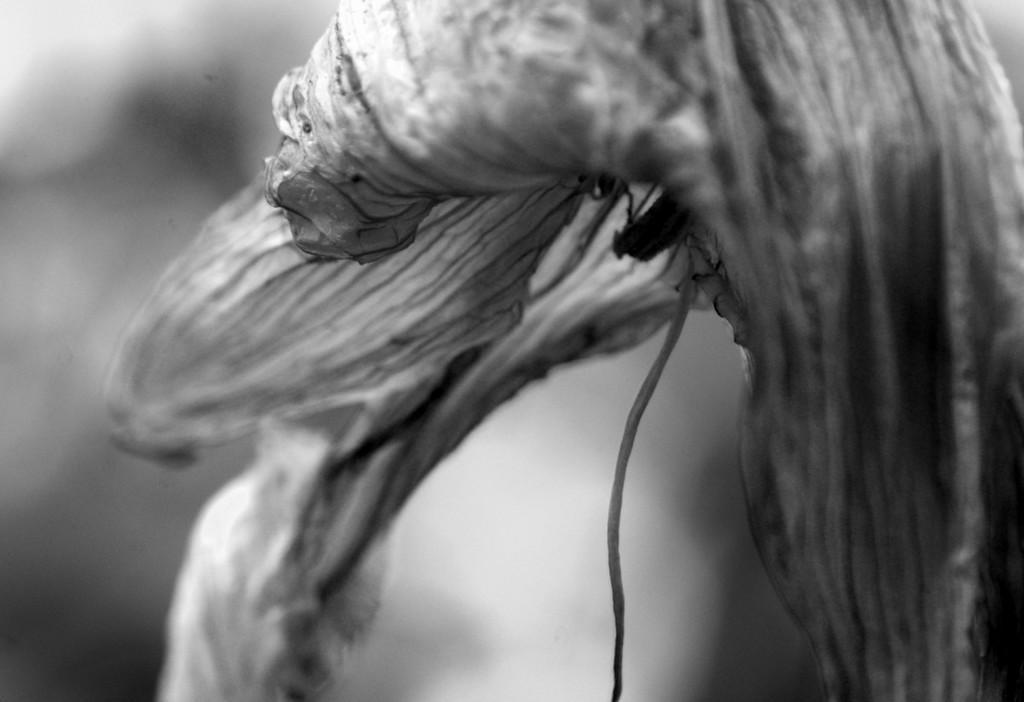In one or two sentences, can you explain what this image depicts? This is black and white picture, we can see insect and flower. In the background it is blur. 